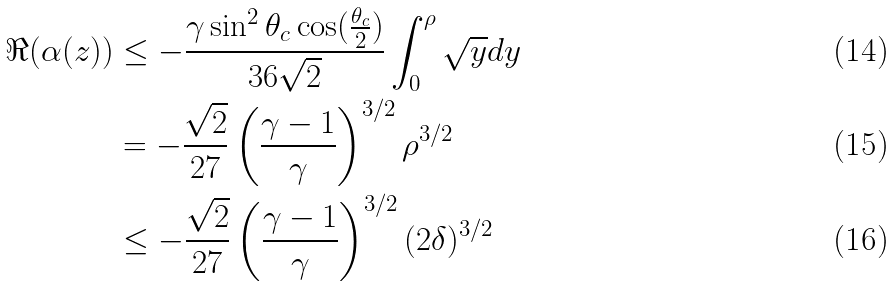Convert formula to latex. <formula><loc_0><loc_0><loc_500><loc_500>\Re ( \alpha ( z ) ) & \leq - \frac { \gamma \sin ^ { 2 } \theta _ { c } \cos ( \frac { \theta _ { c } } 2 ) } { 3 6 \sqrt { 2 } } \int _ { 0 } ^ { \rho } \sqrt { y } d y \\ & = - \frac { \sqrt { 2 } } { 2 7 } \left ( \frac { \gamma - 1 } { \gamma } \right ) ^ { 3 / 2 } \rho ^ { 3 / 2 } \\ & \leq - \frac { \sqrt { 2 } } { 2 7 } \left ( \frac { \gamma - 1 } { \gamma } \right ) ^ { 3 / 2 } ( 2 \delta ) ^ { 3 / 2 }</formula> 